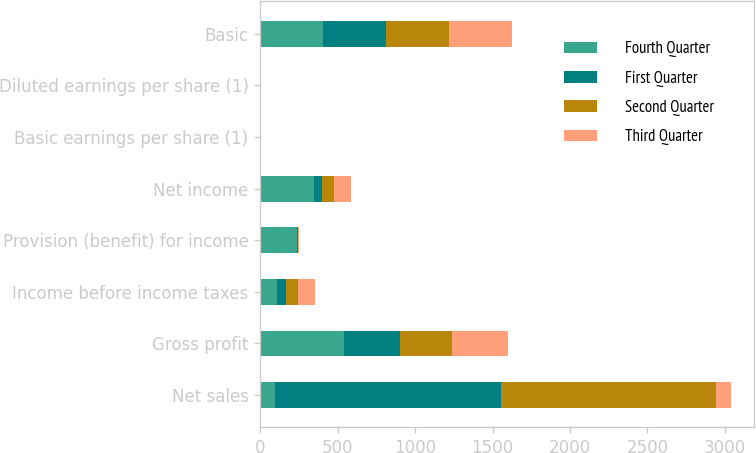Convert chart. <chart><loc_0><loc_0><loc_500><loc_500><stacked_bar_chart><ecel><fcel>Net sales<fcel>Gross profit<fcel>Income before income taxes<fcel>Provision (benefit) for income<fcel>Net income<fcel>Basic earnings per share (1)<fcel>Diluted earnings per share (1)<fcel>Basic<nl><fcel>Fourth Quarter<fcel>94.5<fcel>544<fcel>108<fcel>239<fcel>347<fcel>0.85<fcel>0.82<fcel>408<nl><fcel>First Quarter<fcel>1463<fcel>356<fcel>57<fcel>3<fcel>54<fcel>0.13<fcel>0.13<fcel>407<nl><fcel>Second Quarter<fcel>1387<fcel>341<fcel>81<fcel>5<fcel>76<fcel>0.19<fcel>0.18<fcel>405<nl><fcel>Third Quarter<fcel>94.5<fcel>361<fcel>109<fcel>2<fcel>111<fcel>0.28<fcel>0.26<fcel>404<nl></chart> 